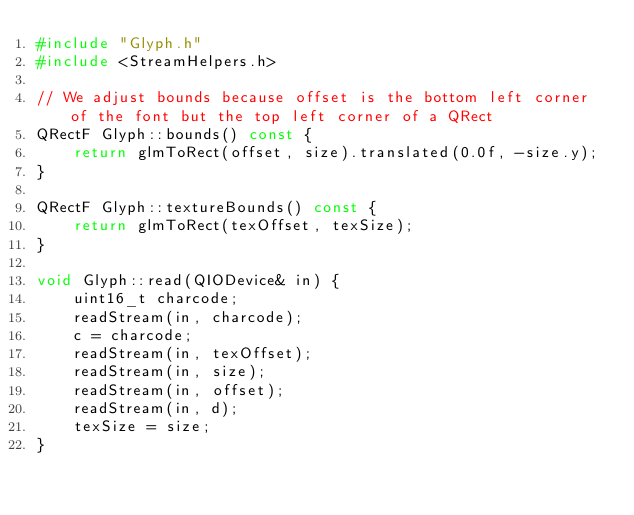<code> <loc_0><loc_0><loc_500><loc_500><_C++_>#include "Glyph.h"
#include <StreamHelpers.h>

// We adjust bounds because offset is the bottom left corner of the font but the top left corner of a QRect
QRectF Glyph::bounds() const {
    return glmToRect(offset, size).translated(0.0f, -size.y);
}

QRectF Glyph::textureBounds() const {
    return glmToRect(texOffset, texSize);
}

void Glyph::read(QIODevice& in) {
    uint16_t charcode;
    readStream(in, charcode);
    c = charcode;
    readStream(in, texOffset);
    readStream(in, size);
    readStream(in, offset);
    readStream(in, d);
    texSize = size;
}
</code> 